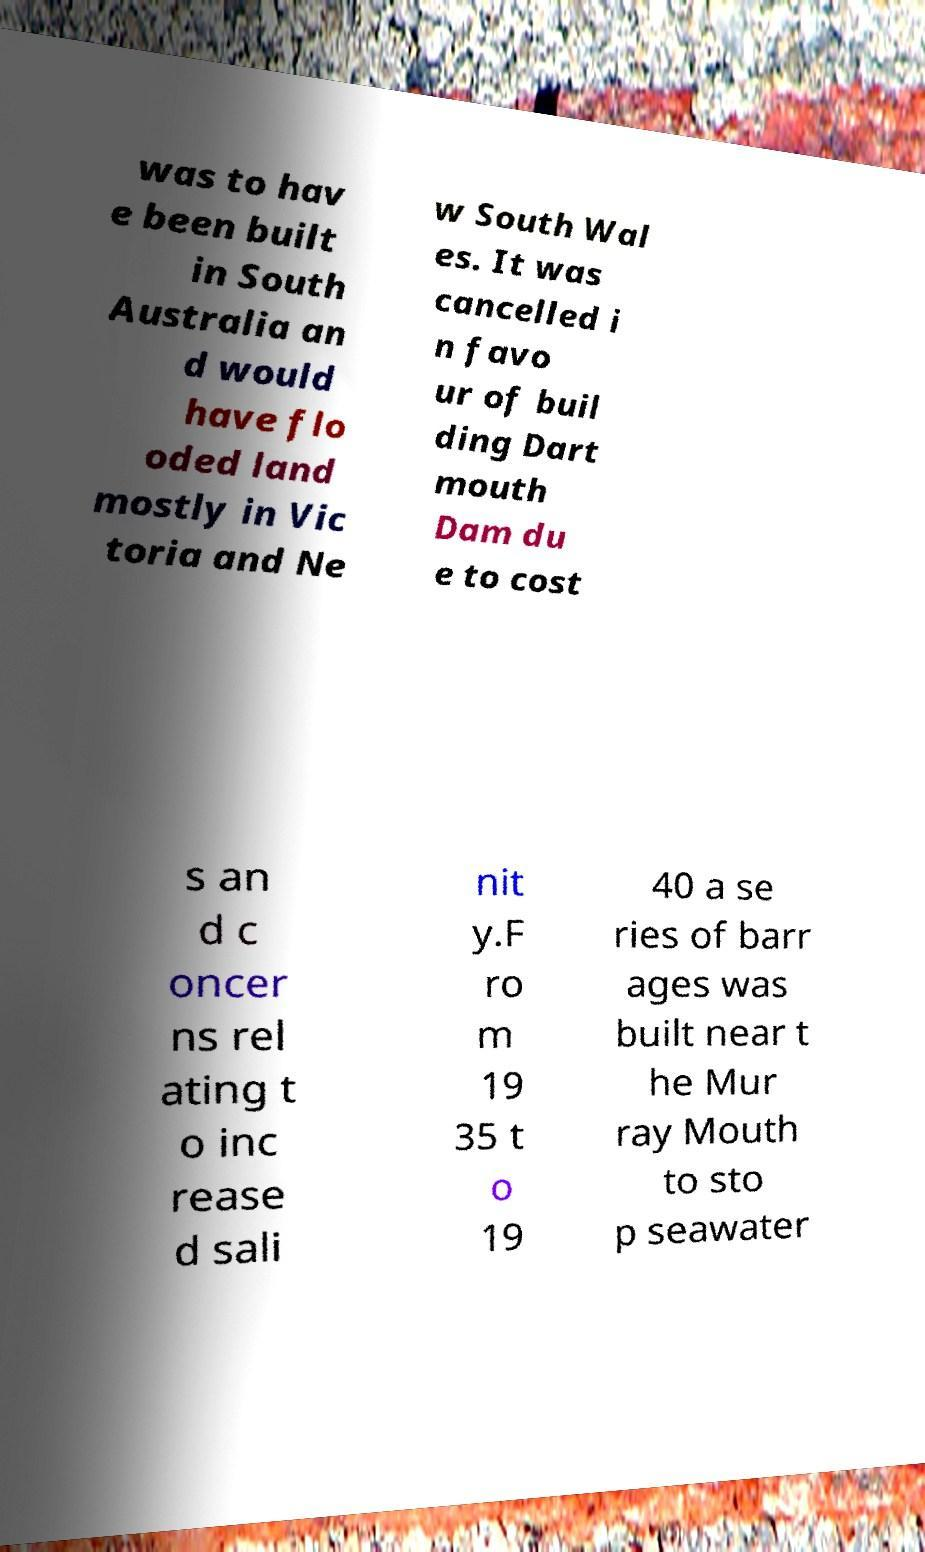Could you extract and type out the text from this image? was to hav e been built in South Australia an d would have flo oded land mostly in Vic toria and Ne w South Wal es. It was cancelled i n favo ur of buil ding Dart mouth Dam du e to cost s an d c oncer ns rel ating t o inc rease d sali nit y.F ro m 19 35 t o 19 40 a se ries of barr ages was built near t he Mur ray Mouth to sto p seawater 